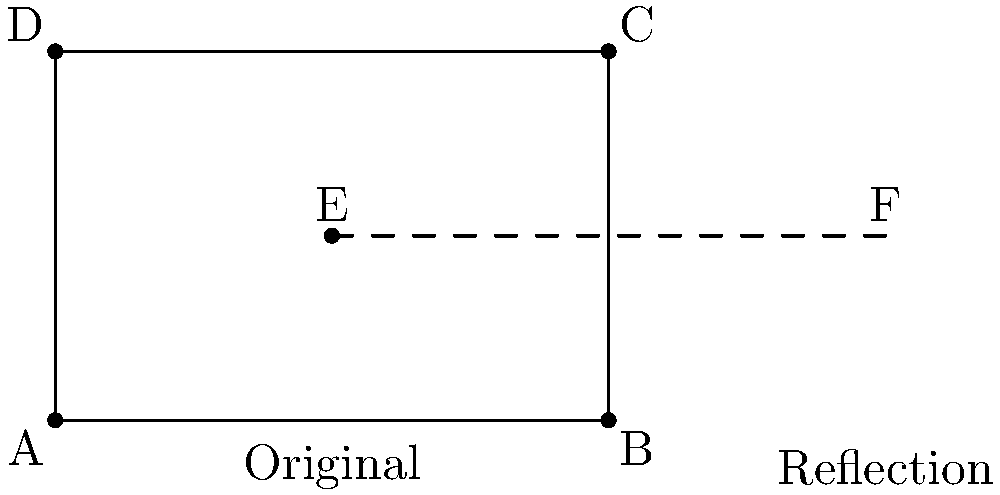In the context of preserving historical church architecture, consider the floor plan of a rectangular church represented by ABCD. If this floor plan is reflected across the line of symmetry EF, what are the coordinates of point C' (the reflection of point C) in relation to the original coordinate system? To find the coordinates of C' after reflection across line EF, we can follow these steps:

1) First, identify the original coordinates:
   C = (6,4)
   E = (3,2)
   F = (9,2)

2) The line of symmetry EF can be described by the equation y = 2.

3) To reflect a point across a horizontal line y = k, we use the formula:
   (x, y) → (x, 2k - y)

4) In this case, k = 2, so our reflection formula is:
   (x, y) → (x, 4 - y)

5) Applying this to point C (6,4):
   x remains the same: 6
   y becomes: 4 - 4 = 0

6) Therefore, the coordinates of C' are (6,0)

This reflection effectively "flips" the church floor plan vertically across the line y = 2, preserving its shape but inverting it top-to-bottom.
Answer: (6,0) 